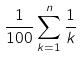Convert formula to latex. <formula><loc_0><loc_0><loc_500><loc_500>\frac { 1 } { 1 0 0 } \sum _ { k = 1 } ^ { n } \frac { 1 } { k }</formula> 